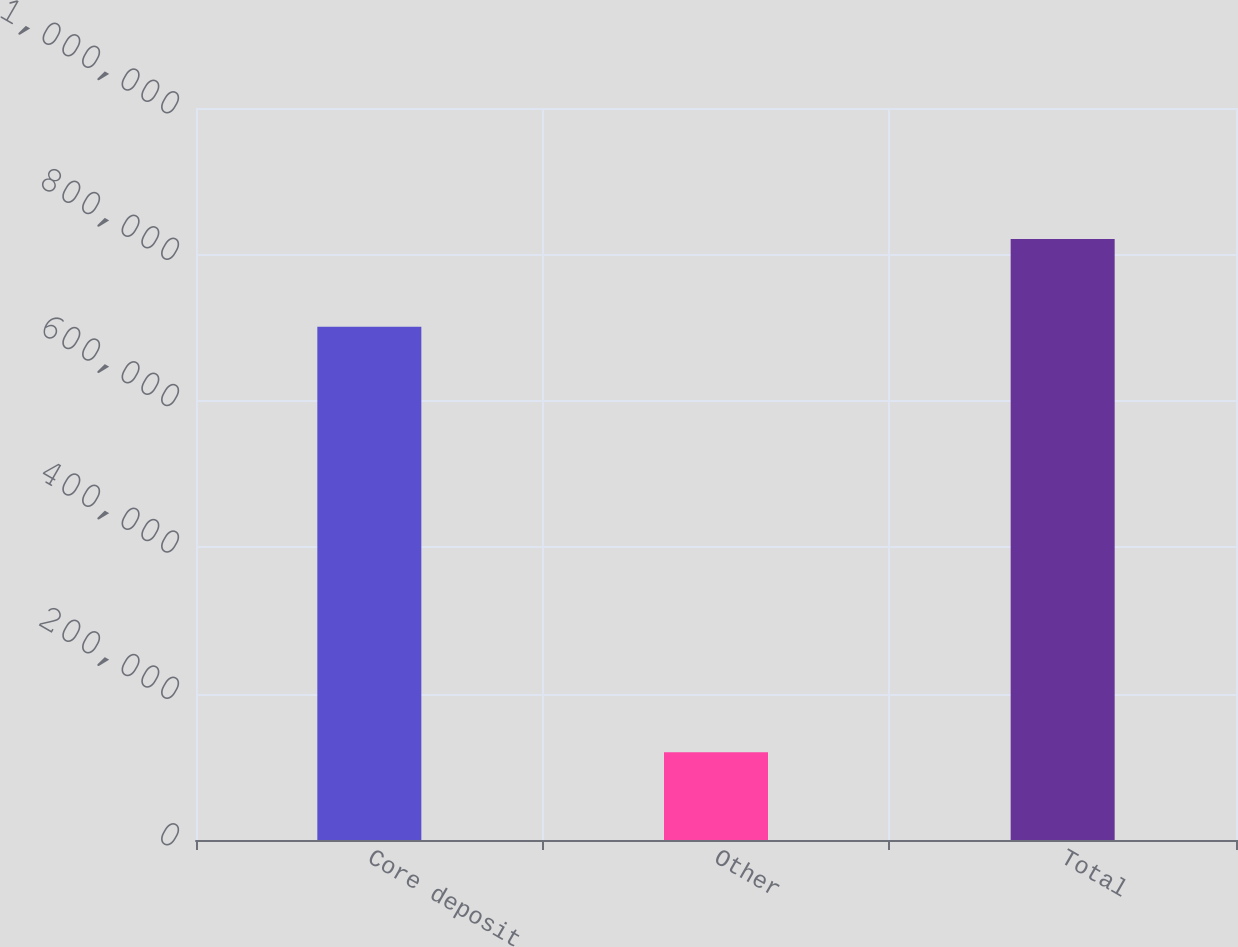Convert chart to OTSL. <chart><loc_0><loc_0><loc_500><loc_500><bar_chart><fcel>Core deposit<fcel>Other<fcel>Total<nl><fcel>701000<fcel>119968<fcel>820968<nl></chart> 